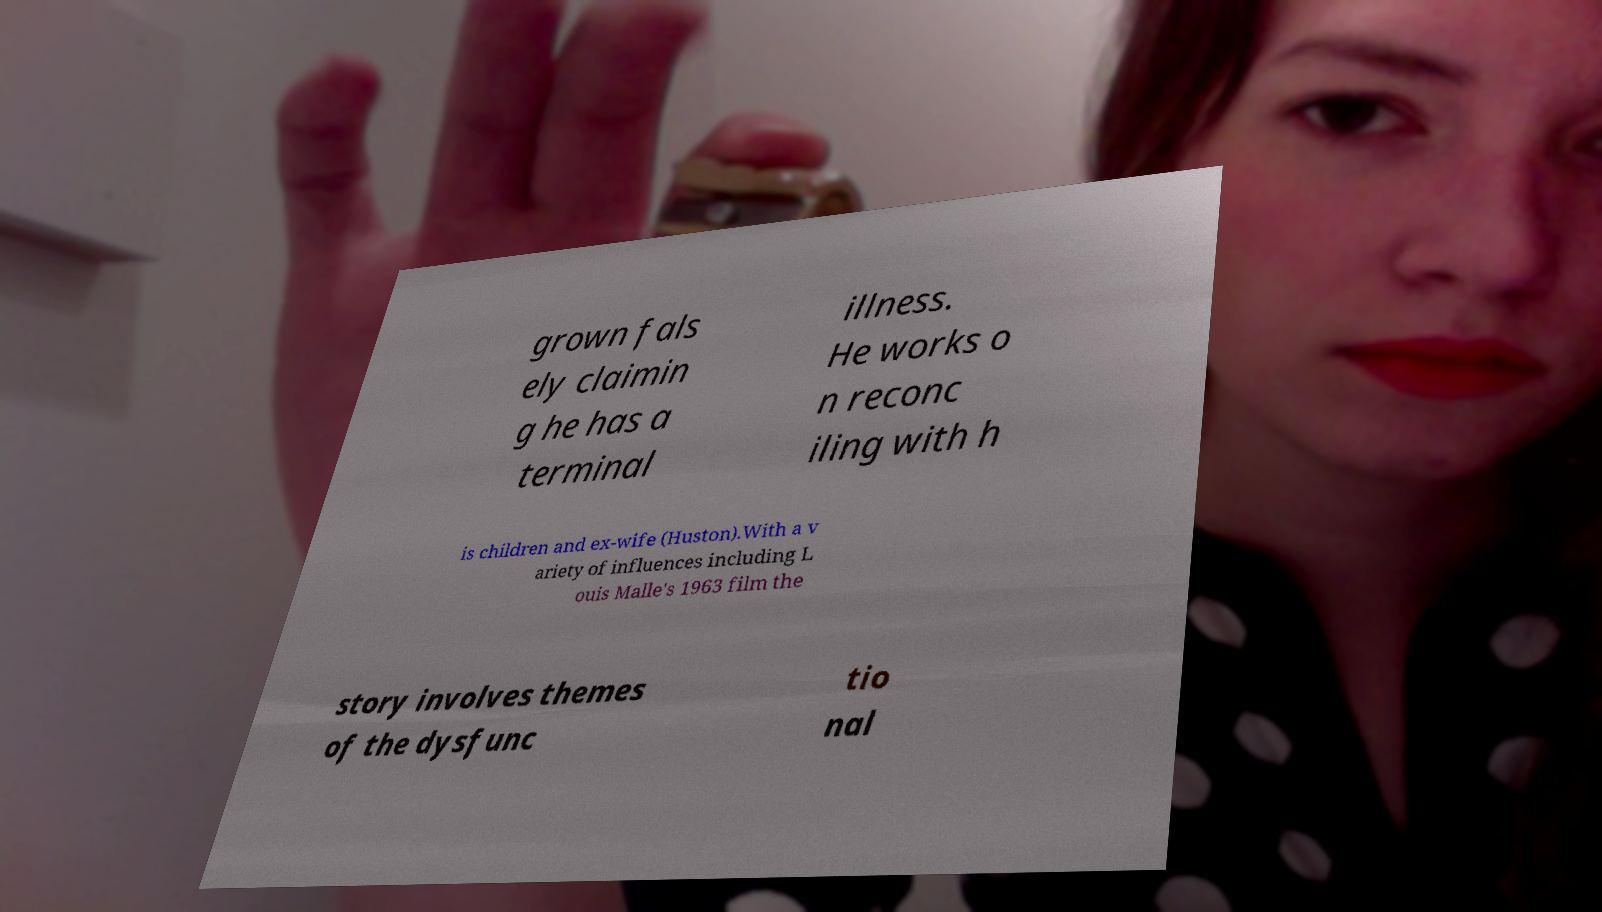Can you accurately transcribe the text from the provided image for me? grown fals ely claimin g he has a terminal illness. He works o n reconc iling with h is children and ex-wife (Huston).With a v ariety of influences including L ouis Malle's 1963 film the story involves themes of the dysfunc tio nal 